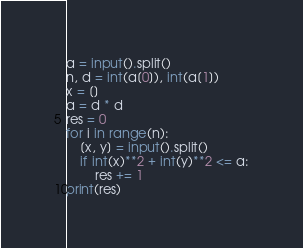Convert code to text. <code><loc_0><loc_0><loc_500><loc_500><_Python_>a = input().split()
n, d = int(a[0]), int(a[1])
x = []
a = d * d
res = 0
for i in range(n):
    [x, y] = input().split()
    if int(x)**2 + int(y)**2 <= a:
        res += 1
print(res)
</code> 